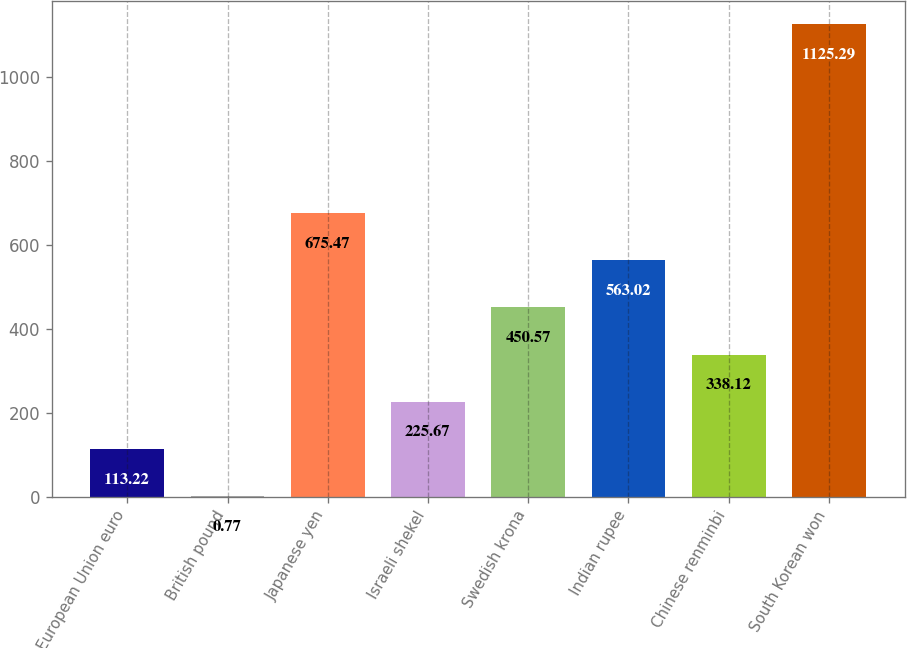Convert chart. <chart><loc_0><loc_0><loc_500><loc_500><bar_chart><fcel>European Union euro<fcel>British pound<fcel>Japanese yen<fcel>Israeli shekel<fcel>Swedish krona<fcel>Indian rupee<fcel>Chinese renminbi<fcel>South Korean won<nl><fcel>113.22<fcel>0.77<fcel>675.47<fcel>225.67<fcel>450.57<fcel>563.02<fcel>338.12<fcel>1125.29<nl></chart> 